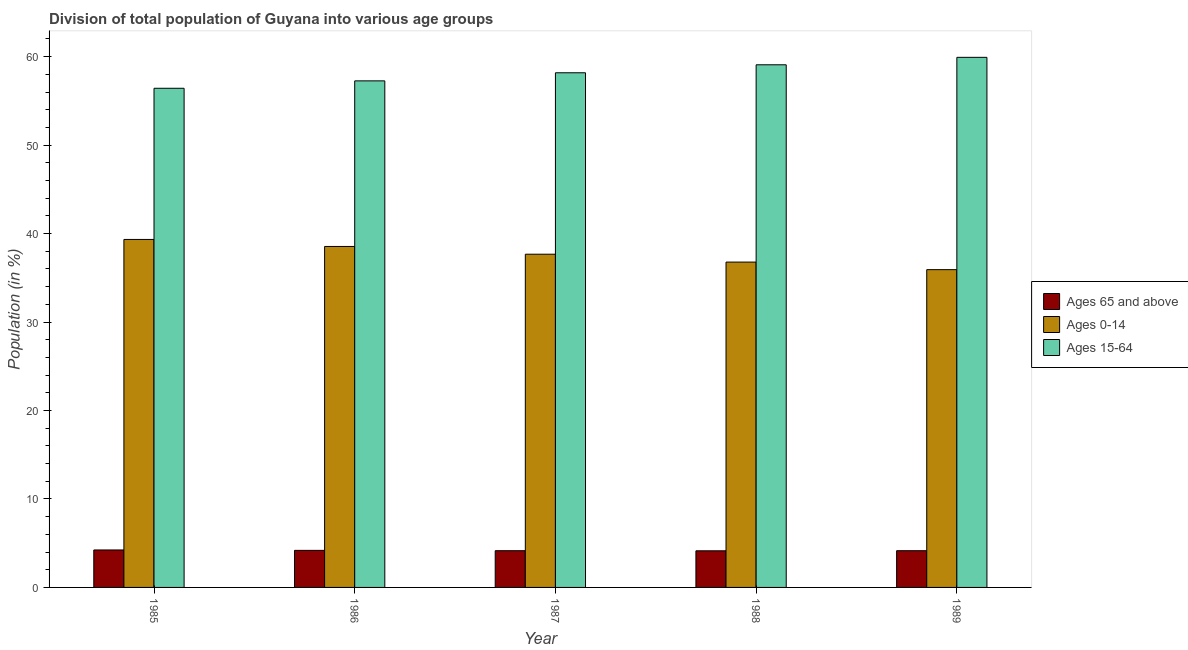How many bars are there on the 2nd tick from the right?
Keep it short and to the point. 3. In how many cases, is the number of bars for a given year not equal to the number of legend labels?
Provide a short and direct response. 0. What is the percentage of population within the age-group 15-64 in 1987?
Your answer should be very brief. 58.18. Across all years, what is the maximum percentage of population within the age-group 0-14?
Provide a succinct answer. 39.34. Across all years, what is the minimum percentage of population within the age-group 15-64?
Your answer should be very brief. 56.43. In which year was the percentage of population within the age-group 0-14 maximum?
Provide a succinct answer. 1985. In which year was the percentage of population within the age-group of 65 and above minimum?
Offer a terse response. 1988. What is the total percentage of population within the age-group 0-14 in the graph?
Keep it short and to the point. 188.25. What is the difference between the percentage of population within the age-group of 65 and above in 1985 and that in 1988?
Offer a terse response. 0.1. What is the difference between the percentage of population within the age-group of 65 and above in 1989 and the percentage of population within the age-group 15-64 in 1986?
Your answer should be very brief. -0.04. What is the average percentage of population within the age-group 15-64 per year?
Offer a very short reply. 58.18. In the year 1986, what is the difference between the percentage of population within the age-group of 65 and above and percentage of population within the age-group 0-14?
Your answer should be compact. 0. What is the ratio of the percentage of population within the age-group 0-14 in 1987 to that in 1989?
Provide a short and direct response. 1.05. What is the difference between the highest and the second highest percentage of population within the age-group 15-64?
Your response must be concise. 0.84. What is the difference between the highest and the lowest percentage of population within the age-group 0-14?
Offer a very short reply. 3.41. In how many years, is the percentage of population within the age-group 0-14 greater than the average percentage of population within the age-group 0-14 taken over all years?
Make the answer very short. 3. What does the 1st bar from the left in 1988 represents?
Give a very brief answer. Ages 65 and above. What does the 3rd bar from the right in 1988 represents?
Give a very brief answer. Ages 65 and above. Is it the case that in every year, the sum of the percentage of population within the age-group of 65 and above and percentage of population within the age-group 0-14 is greater than the percentage of population within the age-group 15-64?
Make the answer very short. No. How many bars are there?
Your answer should be compact. 15. How many years are there in the graph?
Ensure brevity in your answer.  5. What is the difference between two consecutive major ticks on the Y-axis?
Your answer should be very brief. 10. Are the values on the major ticks of Y-axis written in scientific E-notation?
Your answer should be compact. No. Does the graph contain any zero values?
Keep it short and to the point. No. Does the graph contain grids?
Provide a short and direct response. No. Where does the legend appear in the graph?
Give a very brief answer. Center right. How many legend labels are there?
Your response must be concise. 3. How are the legend labels stacked?
Provide a succinct answer. Vertical. What is the title of the graph?
Provide a short and direct response. Division of total population of Guyana into various age groups
. What is the label or title of the X-axis?
Make the answer very short. Year. What is the label or title of the Y-axis?
Provide a succinct answer. Population (in %). What is the Population (in %) in Ages 65 and above in 1985?
Provide a short and direct response. 4.24. What is the Population (in %) in Ages 0-14 in 1985?
Offer a very short reply. 39.34. What is the Population (in %) in Ages 15-64 in 1985?
Ensure brevity in your answer.  56.43. What is the Population (in %) in Ages 65 and above in 1986?
Your response must be concise. 4.19. What is the Population (in %) of Ages 0-14 in 1986?
Provide a succinct answer. 38.55. What is the Population (in %) of Ages 15-64 in 1986?
Make the answer very short. 57.26. What is the Population (in %) in Ages 65 and above in 1987?
Offer a very short reply. 4.15. What is the Population (in %) in Ages 0-14 in 1987?
Ensure brevity in your answer.  37.67. What is the Population (in %) of Ages 15-64 in 1987?
Keep it short and to the point. 58.18. What is the Population (in %) in Ages 65 and above in 1988?
Your response must be concise. 4.14. What is the Population (in %) of Ages 0-14 in 1988?
Offer a very short reply. 36.78. What is the Population (in %) in Ages 15-64 in 1988?
Offer a very short reply. 59.08. What is the Population (in %) of Ages 65 and above in 1989?
Your answer should be very brief. 4.15. What is the Population (in %) in Ages 0-14 in 1989?
Your response must be concise. 35.92. What is the Population (in %) of Ages 15-64 in 1989?
Offer a very short reply. 59.93. Across all years, what is the maximum Population (in %) in Ages 65 and above?
Give a very brief answer. 4.24. Across all years, what is the maximum Population (in %) in Ages 0-14?
Make the answer very short. 39.34. Across all years, what is the maximum Population (in %) of Ages 15-64?
Your answer should be very brief. 59.93. Across all years, what is the minimum Population (in %) in Ages 65 and above?
Ensure brevity in your answer.  4.14. Across all years, what is the minimum Population (in %) in Ages 0-14?
Provide a succinct answer. 35.92. Across all years, what is the minimum Population (in %) in Ages 15-64?
Your answer should be very brief. 56.43. What is the total Population (in %) in Ages 65 and above in the graph?
Your answer should be compact. 20.87. What is the total Population (in %) of Ages 0-14 in the graph?
Your answer should be compact. 188.25. What is the total Population (in %) in Ages 15-64 in the graph?
Provide a succinct answer. 290.88. What is the difference between the Population (in %) in Ages 65 and above in 1985 and that in 1986?
Your answer should be very brief. 0.05. What is the difference between the Population (in %) in Ages 0-14 in 1985 and that in 1986?
Offer a very short reply. 0.79. What is the difference between the Population (in %) of Ages 15-64 in 1985 and that in 1986?
Provide a short and direct response. -0.84. What is the difference between the Population (in %) in Ages 65 and above in 1985 and that in 1987?
Provide a succinct answer. 0.08. What is the difference between the Population (in %) of Ages 0-14 in 1985 and that in 1987?
Make the answer very short. 1.67. What is the difference between the Population (in %) of Ages 15-64 in 1985 and that in 1987?
Ensure brevity in your answer.  -1.75. What is the difference between the Population (in %) in Ages 65 and above in 1985 and that in 1988?
Make the answer very short. 0.1. What is the difference between the Population (in %) in Ages 0-14 in 1985 and that in 1988?
Your answer should be very brief. 2.56. What is the difference between the Population (in %) of Ages 15-64 in 1985 and that in 1988?
Provide a short and direct response. -2.65. What is the difference between the Population (in %) of Ages 65 and above in 1985 and that in 1989?
Provide a succinct answer. 0.08. What is the difference between the Population (in %) in Ages 0-14 in 1985 and that in 1989?
Keep it short and to the point. 3.41. What is the difference between the Population (in %) in Ages 15-64 in 1985 and that in 1989?
Your response must be concise. -3.5. What is the difference between the Population (in %) of Ages 65 and above in 1986 and that in 1987?
Provide a succinct answer. 0.04. What is the difference between the Population (in %) of Ages 0-14 in 1986 and that in 1987?
Provide a short and direct response. 0.88. What is the difference between the Population (in %) of Ages 15-64 in 1986 and that in 1987?
Give a very brief answer. -0.91. What is the difference between the Population (in %) in Ages 65 and above in 1986 and that in 1988?
Keep it short and to the point. 0.05. What is the difference between the Population (in %) of Ages 0-14 in 1986 and that in 1988?
Provide a short and direct response. 1.77. What is the difference between the Population (in %) of Ages 15-64 in 1986 and that in 1988?
Offer a terse response. -1.82. What is the difference between the Population (in %) in Ages 65 and above in 1986 and that in 1989?
Your answer should be compact. 0.04. What is the difference between the Population (in %) of Ages 0-14 in 1986 and that in 1989?
Your answer should be compact. 2.62. What is the difference between the Population (in %) in Ages 15-64 in 1986 and that in 1989?
Give a very brief answer. -2.66. What is the difference between the Population (in %) in Ages 65 and above in 1987 and that in 1988?
Provide a succinct answer. 0.01. What is the difference between the Population (in %) of Ages 0-14 in 1987 and that in 1988?
Keep it short and to the point. 0.89. What is the difference between the Population (in %) in Ages 15-64 in 1987 and that in 1988?
Provide a succinct answer. -0.9. What is the difference between the Population (in %) in Ages 65 and above in 1987 and that in 1989?
Provide a short and direct response. 0. What is the difference between the Population (in %) in Ages 0-14 in 1987 and that in 1989?
Offer a terse response. 1.75. What is the difference between the Population (in %) of Ages 15-64 in 1987 and that in 1989?
Keep it short and to the point. -1.75. What is the difference between the Population (in %) in Ages 65 and above in 1988 and that in 1989?
Provide a short and direct response. -0.01. What is the difference between the Population (in %) of Ages 0-14 in 1988 and that in 1989?
Ensure brevity in your answer.  0.86. What is the difference between the Population (in %) in Ages 15-64 in 1988 and that in 1989?
Your response must be concise. -0.84. What is the difference between the Population (in %) of Ages 65 and above in 1985 and the Population (in %) of Ages 0-14 in 1986?
Ensure brevity in your answer.  -34.31. What is the difference between the Population (in %) of Ages 65 and above in 1985 and the Population (in %) of Ages 15-64 in 1986?
Make the answer very short. -53.03. What is the difference between the Population (in %) in Ages 0-14 in 1985 and the Population (in %) in Ages 15-64 in 1986?
Keep it short and to the point. -17.93. What is the difference between the Population (in %) in Ages 65 and above in 1985 and the Population (in %) in Ages 0-14 in 1987?
Your answer should be very brief. -33.43. What is the difference between the Population (in %) in Ages 65 and above in 1985 and the Population (in %) in Ages 15-64 in 1987?
Your answer should be very brief. -53.94. What is the difference between the Population (in %) in Ages 0-14 in 1985 and the Population (in %) in Ages 15-64 in 1987?
Make the answer very short. -18.84. What is the difference between the Population (in %) in Ages 65 and above in 1985 and the Population (in %) in Ages 0-14 in 1988?
Offer a very short reply. -32.54. What is the difference between the Population (in %) of Ages 65 and above in 1985 and the Population (in %) of Ages 15-64 in 1988?
Provide a succinct answer. -54.85. What is the difference between the Population (in %) in Ages 0-14 in 1985 and the Population (in %) in Ages 15-64 in 1988?
Ensure brevity in your answer.  -19.74. What is the difference between the Population (in %) in Ages 65 and above in 1985 and the Population (in %) in Ages 0-14 in 1989?
Ensure brevity in your answer.  -31.69. What is the difference between the Population (in %) of Ages 65 and above in 1985 and the Population (in %) of Ages 15-64 in 1989?
Offer a terse response. -55.69. What is the difference between the Population (in %) in Ages 0-14 in 1985 and the Population (in %) in Ages 15-64 in 1989?
Offer a very short reply. -20.59. What is the difference between the Population (in %) of Ages 65 and above in 1986 and the Population (in %) of Ages 0-14 in 1987?
Provide a short and direct response. -33.48. What is the difference between the Population (in %) of Ages 65 and above in 1986 and the Population (in %) of Ages 15-64 in 1987?
Your response must be concise. -53.99. What is the difference between the Population (in %) of Ages 0-14 in 1986 and the Population (in %) of Ages 15-64 in 1987?
Offer a terse response. -19.63. What is the difference between the Population (in %) in Ages 65 and above in 1986 and the Population (in %) in Ages 0-14 in 1988?
Keep it short and to the point. -32.59. What is the difference between the Population (in %) of Ages 65 and above in 1986 and the Population (in %) of Ages 15-64 in 1988?
Give a very brief answer. -54.89. What is the difference between the Population (in %) in Ages 0-14 in 1986 and the Population (in %) in Ages 15-64 in 1988?
Provide a short and direct response. -20.54. What is the difference between the Population (in %) of Ages 65 and above in 1986 and the Population (in %) of Ages 0-14 in 1989?
Ensure brevity in your answer.  -31.73. What is the difference between the Population (in %) in Ages 65 and above in 1986 and the Population (in %) in Ages 15-64 in 1989?
Your answer should be very brief. -55.74. What is the difference between the Population (in %) of Ages 0-14 in 1986 and the Population (in %) of Ages 15-64 in 1989?
Provide a succinct answer. -21.38. What is the difference between the Population (in %) of Ages 65 and above in 1987 and the Population (in %) of Ages 0-14 in 1988?
Offer a terse response. -32.63. What is the difference between the Population (in %) of Ages 65 and above in 1987 and the Population (in %) of Ages 15-64 in 1988?
Give a very brief answer. -54.93. What is the difference between the Population (in %) in Ages 0-14 in 1987 and the Population (in %) in Ages 15-64 in 1988?
Your answer should be very brief. -21.41. What is the difference between the Population (in %) in Ages 65 and above in 1987 and the Population (in %) in Ages 0-14 in 1989?
Make the answer very short. -31.77. What is the difference between the Population (in %) of Ages 65 and above in 1987 and the Population (in %) of Ages 15-64 in 1989?
Ensure brevity in your answer.  -55.77. What is the difference between the Population (in %) of Ages 0-14 in 1987 and the Population (in %) of Ages 15-64 in 1989?
Your response must be concise. -22.26. What is the difference between the Population (in %) of Ages 65 and above in 1988 and the Population (in %) of Ages 0-14 in 1989?
Provide a succinct answer. -31.78. What is the difference between the Population (in %) in Ages 65 and above in 1988 and the Population (in %) in Ages 15-64 in 1989?
Your answer should be compact. -55.79. What is the difference between the Population (in %) of Ages 0-14 in 1988 and the Population (in %) of Ages 15-64 in 1989?
Offer a terse response. -23.15. What is the average Population (in %) in Ages 65 and above per year?
Your answer should be very brief. 4.17. What is the average Population (in %) of Ages 0-14 per year?
Offer a terse response. 37.65. What is the average Population (in %) of Ages 15-64 per year?
Make the answer very short. 58.18. In the year 1985, what is the difference between the Population (in %) of Ages 65 and above and Population (in %) of Ages 0-14?
Offer a terse response. -35.1. In the year 1985, what is the difference between the Population (in %) in Ages 65 and above and Population (in %) in Ages 15-64?
Your response must be concise. -52.19. In the year 1985, what is the difference between the Population (in %) in Ages 0-14 and Population (in %) in Ages 15-64?
Offer a terse response. -17.09. In the year 1986, what is the difference between the Population (in %) of Ages 65 and above and Population (in %) of Ages 0-14?
Ensure brevity in your answer.  -34.36. In the year 1986, what is the difference between the Population (in %) of Ages 65 and above and Population (in %) of Ages 15-64?
Your answer should be very brief. -53.07. In the year 1986, what is the difference between the Population (in %) in Ages 0-14 and Population (in %) in Ages 15-64?
Make the answer very short. -18.72. In the year 1987, what is the difference between the Population (in %) of Ages 65 and above and Population (in %) of Ages 0-14?
Your answer should be compact. -33.52. In the year 1987, what is the difference between the Population (in %) of Ages 65 and above and Population (in %) of Ages 15-64?
Make the answer very short. -54.03. In the year 1987, what is the difference between the Population (in %) of Ages 0-14 and Population (in %) of Ages 15-64?
Provide a succinct answer. -20.51. In the year 1988, what is the difference between the Population (in %) of Ages 65 and above and Population (in %) of Ages 0-14?
Ensure brevity in your answer.  -32.64. In the year 1988, what is the difference between the Population (in %) of Ages 65 and above and Population (in %) of Ages 15-64?
Your answer should be compact. -54.94. In the year 1988, what is the difference between the Population (in %) of Ages 0-14 and Population (in %) of Ages 15-64?
Provide a succinct answer. -22.3. In the year 1989, what is the difference between the Population (in %) of Ages 65 and above and Population (in %) of Ages 0-14?
Make the answer very short. -31.77. In the year 1989, what is the difference between the Population (in %) of Ages 65 and above and Population (in %) of Ages 15-64?
Your response must be concise. -55.77. In the year 1989, what is the difference between the Population (in %) of Ages 0-14 and Population (in %) of Ages 15-64?
Offer a terse response. -24. What is the ratio of the Population (in %) of Ages 65 and above in 1985 to that in 1986?
Ensure brevity in your answer.  1.01. What is the ratio of the Population (in %) of Ages 0-14 in 1985 to that in 1986?
Provide a succinct answer. 1.02. What is the ratio of the Population (in %) in Ages 15-64 in 1985 to that in 1986?
Your response must be concise. 0.99. What is the ratio of the Population (in %) of Ages 65 and above in 1985 to that in 1987?
Offer a very short reply. 1.02. What is the ratio of the Population (in %) of Ages 0-14 in 1985 to that in 1987?
Offer a very short reply. 1.04. What is the ratio of the Population (in %) in Ages 15-64 in 1985 to that in 1987?
Give a very brief answer. 0.97. What is the ratio of the Population (in %) in Ages 65 and above in 1985 to that in 1988?
Keep it short and to the point. 1.02. What is the ratio of the Population (in %) in Ages 0-14 in 1985 to that in 1988?
Ensure brevity in your answer.  1.07. What is the ratio of the Population (in %) in Ages 15-64 in 1985 to that in 1988?
Your response must be concise. 0.96. What is the ratio of the Population (in %) in Ages 65 and above in 1985 to that in 1989?
Give a very brief answer. 1.02. What is the ratio of the Population (in %) of Ages 0-14 in 1985 to that in 1989?
Make the answer very short. 1.09. What is the ratio of the Population (in %) of Ages 15-64 in 1985 to that in 1989?
Make the answer very short. 0.94. What is the ratio of the Population (in %) in Ages 65 and above in 1986 to that in 1987?
Offer a very short reply. 1.01. What is the ratio of the Population (in %) of Ages 0-14 in 1986 to that in 1987?
Your answer should be compact. 1.02. What is the ratio of the Population (in %) in Ages 15-64 in 1986 to that in 1987?
Your answer should be compact. 0.98. What is the ratio of the Population (in %) in Ages 65 and above in 1986 to that in 1988?
Make the answer very short. 1.01. What is the ratio of the Population (in %) of Ages 0-14 in 1986 to that in 1988?
Ensure brevity in your answer.  1.05. What is the ratio of the Population (in %) in Ages 15-64 in 1986 to that in 1988?
Provide a short and direct response. 0.97. What is the ratio of the Population (in %) in Ages 65 and above in 1986 to that in 1989?
Offer a very short reply. 1.01. What is the ratio of the Population (in %) of Ages 0-14 in 1986 to that in 1989?
Provide a succinct answer. 1.07. What is the ratio of the Population (in %) in Ages 15-64 in 1986 to that in 1989?
Your response must be concise. 0.96. What is the ratio of the Population (in %) of Ages 0-14 in 1987 to that in 1988?
Make the answer very short. 1.02. What is the ratio of the Population (in %) of Ages 15-64 in 1987 to that in 1988?
Offer a terse response. 0.98. What is the ratio of the Population (in %) of Ages 65 and above in 1987 to that in 1989?
Your response must be concise. 1. What is the ratio of the Population (in %) in Ages 0-14 in 1987 to that in 1989?
Make the answer very short. 1.05. What is the ratio of the Population (in %) in Ages 15-64 in 1987 to that in 1989?
Make the answer very short. 0.97. What is the ratio of the Population (in %) of Ages 0-14 in 1988 to that in 1989?
Give a very brief answer. 1.02. What is the ratio of the Population (in %) in Ages 15-64 in 1988 to that in 1989?
Your answer should be very brief. 0.99. What is the difference between the highest and the second highest Population (in %) of Ages 65 and above?
Provide a succinct answer. 0.05. What is the difference between the highest and the second highest Population (in %) of Ages 0-14?
Ensure brevity in your answer.  0.79. What is the difference between the highest and the second highest Population (in %) of Ages 15-64?
Your answer should be compact. 0.84. What is the difference between the highest and the lowest Population (in %) of Ages 65 and above?
Ensure brevity in your answer.  0.1. What is the difference between the highest and the lowest Population (in %) of Ages 0-14?
Your answer should be very brief. 3.41. What is the difference between the highest and the lowest Population (in %) in Ages 15-64?
Offer a terse response. 3.5. 